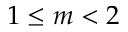<formula> <loc_0><loc_0><loc_500><loc_500>1 \leq m < 2</formula> 